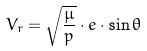<formula> <loc_0><loc_0><loc_500><loc_500>V _ { r } = \sqrt { \frac { \mu } { p } } \cdot e \cdot \sin \theta</formula> 